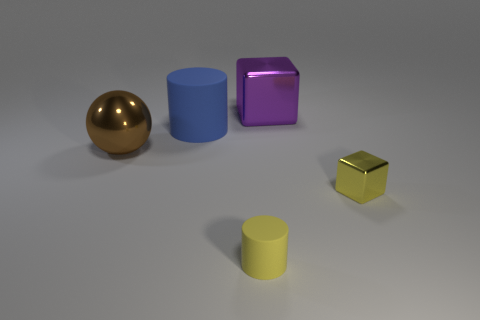Add 2 large brown metallic things. How many objects exist? 7 Subtract all cylinders. How many objects are left? 3 Subtract all tiny cyan spheres. Subtract all large brown things. How many objects are left? 4 Add 2 purple blocks. How many purple blocks are left? 3 Add 4 small matte things. How many small matte things exist? 5 Subtract 0 red cubes. How many objects are left? 5 